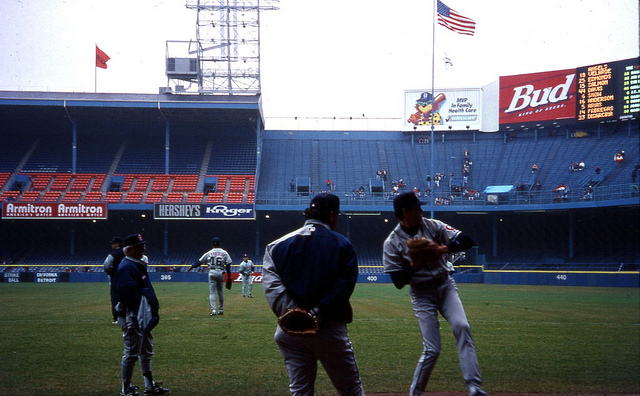<image>Whose home stadium is this? It is unknown whose home stadium is this. It could belong to multiple teams such as 'white sox', 'dodgers', 'angels', 'yankees', 'blue jays', 'pittsburgh pirates', 'twins', or 'cubs'. Whose home stadium is this? I don't know whose home stadium this is. It could belong to the White Sox, Dodgers, Angels, Yankees, Blue Jays, Pittsburgh Pirates, Twins, or Cubs. 